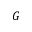<formula> <loc_0><loc_0><loc_500><loc_500>G</formula> 